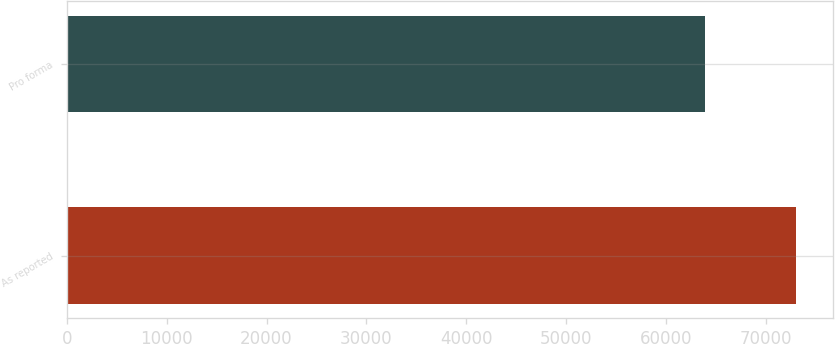Convert chart. <chart><loc_0><loc_0><loc_500><loc_500><bar_chart><fcel>As reported<fcel>Pro forma<nl><fcel>73069<fcel>63926<nl></chart> 